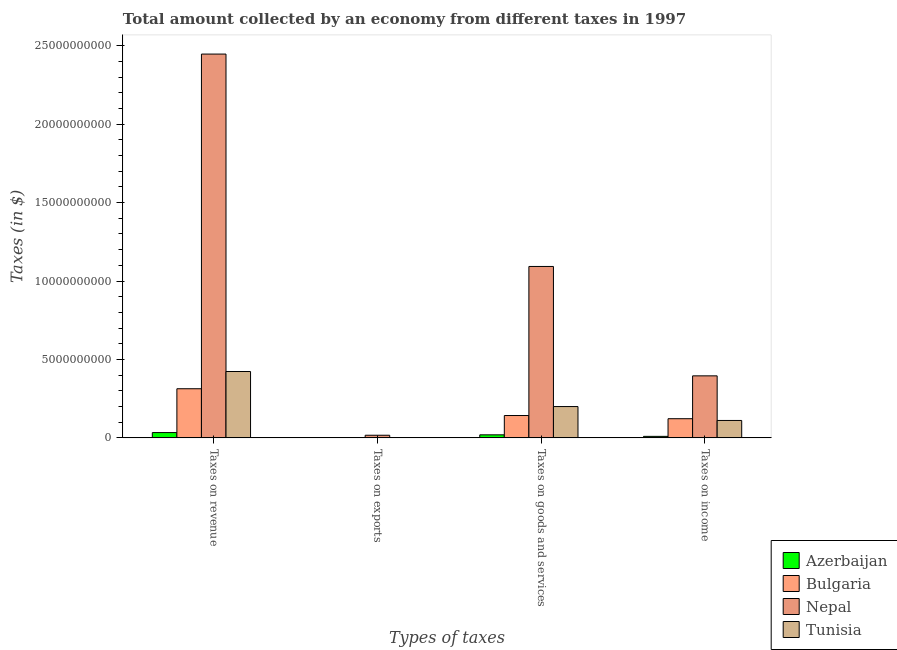How many different coloured bars are there?
Give a very brief answer. 4. Are the number of bars per tick equal to the number of legend labels?
Offer a terse response. Yes. What is the label of the 2nd group of bars from the left?
Offer a very short reply. Taxes on exports. What is the amount collected as tax on exports in Tunisia?
Your response must be concise. 1.02e+07. Across all countries, what is the maximum amount collected as tax on income?
Offer a very short reply. 3.95e+09. Across all countries, what is the minimum amount collected as tax on exports?
Offer a terse response. 9.16e+06. In which country was the amount collected as tax on goods maximum?
Keep it short and to the point. Nepal. In which country was the amount collected as tax on goods minimum?
Give a very brief answer. Azerbaijan. What is the total amount collected as tax on income in the graph?
Make the answer very short. 6.38e+09. What is the difference between the amount collected as tax on income in Bulgaria and that in Nepal?
Your answer should be very brief. -2.73e+09. What is the difference between the amount collected as tax on income in Tunisia and the amount collected as tax on revenue in Bulgaria?
Offer a terse response. -2.02e+09. What is the average amount collected as tax on goods per country?
Ensure brevity in your answer.  3.64e+09. What is the difference between the amount collected as tax on exports and amount collected as tax on revenue in Azerbaijan?
Your response must be concise. -3.29e+08. What is the ratio of the amount collected as tax on goods in Azerbaijan to that in Nepal?
Offer a terse response. 0.02. Is the amount collected as tax on revenue in Nepal less than that in Bulgaria?
Provide a succinct answer. No. Is the difference between the amount collected as tax on exports in Nepal and Tunisia greater than the difference between the amount collected as tax on goods in Nepal and Tunisia?
Provide a succinct answer. No. What is the difference between the highest and the second highest amount collected as tax on exports?
Your response must be concise. 1.56e+08. What is the difference between the highest and the lowest amount collected as tax on goods?
Make the answer very short. 1.07e+1. Is it the case that in every country, the sum of the amount collected as tax on goods and amount collected as tax on income is greater than the sum of amount collected as tax on revenue and amount collected as tax on exports?
Make the answer very short. No. What does the 3rd bar from the left in Taxes on income represents?
Give a very brief answer. Nepal. How many bars are there?
Ensure brevity in your answer.  16. Are all the bars in the graph horizontal?
Keep it short and to the point. No. Are the values on the major ticks of Y-axis written in scientific E-notation?
Offer a terse response. No. Does the graph contain grids?
Offer a terse response. No. Where does the legend appear in the graph?
Your answer should be compact. Bottom right. How many legend labels are there?
Give a very brief answer. 4. What is the title of the graph?
Your answer should be compact. Total amount collected by an economy from different taxes in 1997. What is the label or title of the X-axis?
Ensure brevity in your answer.  Types of taxes. What is the label or title of the Y-axis?
Provide a succinct answer. Taxes (in $). What is the Taxes (in $) of Azerbaijan in Taxes on revenue?
Your answer should be very brief. 3.38e+08. What is the Taxes (in $) of Bulgaria in Taxes on revenue?
Offer a very short reply. 3.13e+09. What is the Taxes (in $) of Nepal in Taxes on revenue?
Provide a short and direct response. 2.45e+1. What is the Taxes (in $) in Tunisia in Taxes on revenue?
Your response must be concise. 4.23e+09. What is the Taxes (in $) of Azerbaijan in Taxes on exports?
Provide a short and direct response. 9.16e+06. What is the Taxes (in $) of Bulgaria in Taxes on exports?
Ensure brevity in your answer.  1.22e+07. What is the Taxes (in $) of Nepal in Taxes on exports?
Provide a short and direct response. 1.68e+08. What is the Taxes (in $) of Tunisia in Taxes on exports?
Offer a terse response. 1.02e+07. What is the Taxes (in $) of Azerbaijan in Taxes on goods and services?
Keep it short and to the point. 1.94e+08. What is the Taxes (in $) of Bulgaria in Taxes on goods and services?
Your response must be concise. 1.42e+09. What is the Taxes (in $) of Nepal in Taxes on goods and services?
Provide a succinct answer. 1.09e+1. What is the Taxes (in $) of Tunisia in Taxes on goods and services?
Your answer should be compact. 2.00e+09. What is the Taxes (in $) of Azerbaijan in Taxes on income?
Provide a short and direct response. 9.60e+07. What is the Taxes (in $) in Bulgaria in Taxes on income?
Your answer should be very brief. 1.22e+09. What is the Taxes (in $) of Nepal in Taxes on income?
Your answer should be compact. 3.95e+09. What is the Taxes (in $) of Tunisia in Taxes on income?
Ensure brevity in your answer.  1.11e+09. Across all Types of taxes, what is the maximum Taxes (in $) of Azerbaijan?
Keep it short and to the point. 3.38e+08. Across all Types of taxes, what is the maximum Taxes (in $) of Bulgaria?
Ensure brevity in your answer.  3.13e+09. Across all Types of taxes, what is the maximum Taxes (in $) of Nepal?
Offer a very short reply. 2.45e+1. Across all Types of taxes, what is the maximum Taxes (in $) of Tunisia?
Offer a very short reply. 4.23e+09. Across all Types of taxes, what is the minimum Taxes (in $) in Azerbaijan?
Ensure brevity in your answer.  9.16e+06. Across all Types of taxes, what is the minimum Taxes (in $) in Bulgaria?
Give a very brief answer. 1.22e+07. Across all Types of taxes, what is the minimum Taxes (in $) in Nepal?
Provide a short and direct response. 1.68e+08. Across all Types of taxes, what is the minimum Taxes (in $) in Tunisia?
Your answer should be compact. 1.02e+07. What is the total Taxes (in $) in Azerbaijan in the graph?
Provide a succinct answer. 6.36e+08. What is the total Taxes (in $) in Bulgaria in the graph?
Provide a short and direct response. 5.79e+09. What is the total Taxes (in $) in Nepal in the graph?
Your response must be concise. 3.95e+1. What is the total Taxes (in $) of Tunisia in the graph?
Provide a succinct answer. 7.35e+09. What is the difference between the Taxes (in $) in Azerbaijan in Taxes on revenue and that in Taxes on exports?
Make the answer very short. 3.29e+08. What is the difference between the Taxes (in $) in Bulgaria in Taxes on revenue and that in Taxes on exports?
Ensure brevity in your answer.  3.12e+09. What is the difference between the Taxes (in $) of Nepal in Taxes on revenue and that in Taxes on exports?
Provide a short and direct response. 2.43e+1. What is the difference between the Taxes (in $) in Tunisia in Taxes on revenue and that in Taxes on exports?
Your answer should be very brief. 4.22e+09. What is the difference between the Taxes (in $) in Azerbaijan in Taxes on revenue and that in Taxes on goods and services?
Your answer should be compact. 1.44e+08. What is the difference between the Taxes (in $) of Bulgaria in Taxes on revenue and that in Taxes on goods and services?
Your answer should be very brief. 1.71e+09. What is the difference between the Taxes (in $) of Nepal in Taxes on revenue and that in Taxes on goods and services?
Keep it short and to the point. 1.35e+1. What is the difference between the Taxes (in $) of Tunisia in Taxes on revenue and that in Taxes on goods and services?
Make the answer very short. 2.23e+09. What is the difference between the Taxes (in $) in Azerbaijan in Taxes on revenue and that in Taxes on income?
Your response must be concise. 2.42e+08. What is the difference between the Taxes (in $) in Bulgaria in Taxes on revenue and that in Taxes on income?
Offer a very short reply. 1.91e+09. What is the difference between the Taxes (in $) in Nepal in Taxes on revenue and that in Taxes on income?
Offer a very short reply. 2.05e+1. What is the difference between the Taxes (in $) of Tunisia in Taxes on revenue and that in Taxes on income?
Ensure brevity in your answer.  3.12e+09. What is the difference between the Taxes (in $) in Azerbaijan in Taxes on exports and that in Taxes on goods and services?
Offer a terse response. -1.84e+08. What is the difference between the Taxes (in $) of Bulgaria in Taxes on exports and that in Taxes on goods and services?
Your response must be concise. -1.41e+09. What is the difference between the Taxes (in $) in Nepal in Taxes on exports and that in Taxes on goods and services?
Offer a terse response. -1.08e+1. What is the difference between the Taxes (in $) of Tunisia in Taxes on exports and that in Taxes on goods and services?
Your answer should be compact. -1.99e+09. What is the difference between the Taxes (in $) in Azerbaijan in Taxes on exports and that in Taxes on income?
Offer a terse response. -8.68e+07. What is the difference between the Taxes (in $) of Bulgaria in Taxes on exports and that in Taxes on income?
Make the answer very short. -1.21e+09. What is the difference between the Taxes (in $) in Nepal in Taxes on exports and that in Taxes on income?
Give a very brief answer. -3.79e+09. What is the difference between the Taxes (in $) in Tunisia in Taxes on exports and that in Taxes on income?
Provide a short and direct response. -1.10e+09. What is the difference between the Taxes (in $) of Azerbaijan in Taxes on goods and services and that in Taxes on income?
Give a very brief answer. 9.75e+07. What is the difference between the Taxes (in $) of Bulgaria in Taxes on goods and services and that in Taxes on income?
Your answer should be compact. 2.02e+08. What is the difference between the Taxes (in $) in Nepal in Taxes on goods and services and that in Taxes on income?
Offer a terse response. 6.98e+09. What is the difference between the Taxes (in $) in Tunisia in Taxes on goods and services and that in Taxes on income?
Your response must be concise. 8.86e+08. What is the difference between the Taxes (in $) of Azerbaijan in Taxes on revenue and the Taxes (in $) of Bulgaria in Taxes on exports?
Your response must be concise. 3.26e+08. What is the difference between the Taxes (in $) of Azerbaijan in Taxes on revenue and the Taxes (in $) of Nepal in Taxes on exports?
Provide a short and direct response. 1.70e+08. What is the difference between the Taxes (in $) in Azerbaijan in Taxes on revenue and the Taxes (in $) in Tunisia in Taxes on exports?
Your answer should be compact. 3.28e+08. What is the difference between the Taxes (in $) in Bulgaria in Taxes on revenue and the Taxes (in $) in Nepal in Taxes on exports?
Provide a short and direct response. 2.96e+09. What is the difference between the Taxes (in $) of Bulgaria in Taxes on revenue and the Taxes (in $) of Tunisia in Taxes on exports?
Provide a short and direct response. 3.12e+09. What is the difference between the Taxes (in $) of Nepal in Taxes on revenue and the Taxes (in $) of Tunisia in Taxes on exports?
Your response must be concise. 2.45e+1. What is the difference between the Taxes (in $) in Azerbaijan in Taxes on revenue and the Taxes (in $) in Bulgaria in Taxes on goods and services?
Give a very brief answer. -1.09e+09. What is the difference between the Taxes (in $) in Azerbaijan in Taxes on revenue and the Taxes (in $) in Nepal in Taxes on goods and services?
Offer a terse response. -1.06e+1. What is the difference between the Taxes (in $) of Azerbaijan in Taxes on revenue and the Taxes (in $) of Tunisia in Taxes on goods and services?
Provide a short and direct response. -1.66e+09. What is the difference between the Taxes (in $) of Bulgaria in Taxes on revenue and the Taxes (in $) of Nepal in Taxes on goods and services?
Make the answer very short. -7.80e+09. What is the difference between the Taxes (in $) of Bulgaria in Taxes on revenue and the Taxes (in $) of Tunisia in Taxes on goods and services?
Provide a succinct answer. 1.14e+09. What is the difference between the Taxes (in $) in Nepal in Taxes on revenue and the Taxes (in $) in Tunisia in Taxes on goods and services?
Ensure brevity in your answer.  2.25e+1. What is the difference between the Taxes (in $) of Azerbaijan in Taxes on revenue and the Taxes (in $) of Bulgaria in Taxes on income?
Your response must be concise. -8.84e+08. What is the difference between the Taxes (in $) in Azerbaijan in Taxes on revenue and the Taxes (in $) in Nepal in Taxes on income?
Provide a succinct answer. -3.62e+09. What is the difference between the Taxes (in $) in Azerbaijan in Taxes on revenue and the Taxes (in $) in Tunisia in Taxes on income?
Your answer should be compact. -7.72e+08. What is the difference between the Taxes (in $) in Bulgaria in Taxes on revenue and the Taxes (in $) in Nepal in Taxes on income?
Offer a terse response. -8.22e+08. What is the difference between the Taxes (in $) of Bulgaria in Taxes on revenue and the Taxes (in $) of Tunisia in Taxes on income?
Your answer should be compact. 2.02e+09. What is the difference between the Taxes (in $) in Nepal in Taxes on revenue and the Taxes (in $) in Tunisia in Taxes on income?
Your answer should be compact. 2.34e+1. What is the difference between the Taxes (in $) of Azerbaijan in Taxes on exports and the Taxes (in $) of Bulgaria in Taxes on goods and services?
Provide a short and direct response. -1.42e+09. What is the difference between the Taxes (in $) in Azerbaijan in Taxes on exports and the Taxes (in $) in Nepal in Taxes on goods and services?
Ensure brevity in your answer.  -1.09e+1. What is the difference between the Taxes (in $) in Azerbaijan in Taxes on exports and the Taxes (in $) in Tunisia in Taxes on goods and services?
Make the answer very short. -1.99e+09. What is the difference between the Taxes (in $) in Bulgaria in Taxes on exports and the Taxes (in $) in Nepal in Taxes on goods and services?
Ensure brevity in your answer.  -1.09e+1. What is the difference between the Taxes (in $) of Bulgaria in Taxes on exports and the Taxes (in $) of Tunisia in Taxes on goods and services?
Your answer should be compact. -1.98e+09. What is the difference between the Taxes (in $) of Nepal in Taxes on exports and the Taxes (in $) of Tunisia in Taxes on goods and services?
Keep it short and to the point. -1.83e+09. What is the difference between the Taxes (in $) of Azerbaijan in Taxes on exports and the Taxes (in $) of Bulgaria in Taxes on income?
Provide a short and direct response. -1.21e+09. What is the difference between the Taxes (in $) of Azerbaijan in Taxes on exports and the Taxes (in $) of Nepal in Taxes on income?
Make the answer very short. -3.94e+09. What is the difference between the Taxes (in $) in Azerbaijan in Taxes on exports and the Taxes (in $) in Tunisia in Taxes on income?
Your answer should be compact. -1.10e+09. What is the difference between the Taxes (in $) in Bulgaria in Taxes on exports and the Taxes (in $) in Nepal in Taxes on income?
Offer a terse response. -3.94e+09. What is the difference between the Taxes (in $) of Bulgaria in Taxes on exports and the Taxes (in $) of Tunisia in Taxes on income?
Make the answer very short. -1.10e+09. What is the difference between the Taxes (in $) of Nepal in Taxes on exports and the Taxes (in $) of Tunisia in Taxes on income?
Your answer should be very brief. -9.42e+08. What is the difference between the Taxes (in $) of Azerbaijan in Taxes on goods and services and the Taxes (in $) of Bulgaria in Taxes on income?
Your answer should be very brief. -1.03e+09. What is the difference between the Taxes (in $) in Azerbaijan in Taxes on goods and services and the Taxes (in $) in Nepal in Taxes on income?
Provide a short and direct response. -3.76e+09. What is the difference between the Taxes (in $) in Azerbaijan in Taxes on goods and services and the Taxes (in $) in Tunisia in Taxes on income?
Ensure brevity in your answer.  -9.16e+08. What is the difference between the Taxes (in $) of Bulgaria in Taxes on goods and services and the Taxes (in $) of Nepal in Taxes on income?
Keep it short and to the point. -2.53e+09. What is the difference between the Taxes (in $) in Bulgaria in Taxes on goods and services and the Taxes (in $) in Tunisia in Taxes on income?
Your answer should be very brief. 3.14e+08. What is the difference between the Taxes (in $) of Nepal in Taxes on goods and services and the Taxes (in $) of Tunisia in Taxes on income?
Provide a succinct answer. 9.82e+09. What is the average Taxes (in $) of Azerbaijan per Types of taxes?
Keep it short and to the point. 1.59e+08. What is the average Taxes (in $) in Bulgaria per Types of taxes?
Give a very brief answer. 1.45e+09. What is the average Taxes (in $) of Nepal per Types of taxes?
Your answer should be very brief. 9.88e+09. What is the average Taxes (in $) in Tunisia per Types of taxes?
Provide a succinct answer. 1.84e+09. What is the difference between the Taxes (in $) in Azerbaijan and Taxes (in $) in Bulgaria in Taxes on revenue?
Offer a very short reply. -2.79e+09. What is the difference between the Taxes (in $) in Azerbaijan and Taxes (in $) in Nepal in Taxes on revenue?
Make the answer very short. -2.41e+1. What is the difference between the Taxes (in $) in Azerbaijan and Taxes (in $) in Tunisia in Taxes on revenue?
Ensure brevity in your answer.  -3.89e+09. What is the difference between the Taxes (in $) of Bulgaria and Taxes (in $) of Nepal in Taxes on revenue?
Your answer should be compact. -2.13e+1. What is the difference between the Taxes (in $) in Bulgaria and Taxes (in $) in Tunisia in Taxes on revenue?
Your answer should be compact. -1.10e+09. What is the difference between the Taxes (in $) of Nepal and Taxes (in $) of Tunisia in Taxes on revenue?
Offer a very short reply. 2.02e+1. What is the difference between the Taxes (in $) of Azerbaijan and Taxes (in $) of Bulgaria in Taxes on exports?
Ensure brevity in your answer.  -3.06e+06. What is the difference between the Taxes (in $) of Azerbaijan and Taxes (in $) of Nepal in Taxes on exports?
Your response must be concise. -1.59e+08. What is the difference between the Taxes (in $) in Azerbaijan and Taxes (in $) in Tunisia in Taxes on exports?
Provide a short and direct response. -1.04e+06. What is the difference between the Taxes (in $) of Bulgaria and Taxes (in $) of Nepal in Taxes on exports?
Your response must be concise. -1.56e+08. What is the difference between the Taxes (in $) in Bulgaria and Taxes (in $) in Tunisia in Taxes on exports?
Provide a short and direct response. 2.02e+06. What is the difference between the Taxes (in $) in Nepal and Taxes (in $) in Tunisia in Taxes on exports?
Offer a very short reply. 1.58e+08. What is the difference between the Taxes (in $) of Azerbaijan and Taxes (in $) of Bulgaria in Taxes on goods and services?
Make the answer very short. -1.23e+09. What is the difference between the Taxes (in $) in Azerbaijan and Taxes (in $) in Nepal in Taxes on goods and services?
Provide a succinct answer. -1.07e+1. What is the difference between the Taxes (in $) in Azerbaijan and Taxes (in $) in Tunisia in Taxes on goods and services?
Your response must be concise. -1.80e+09. What is the difference between the Taxes (in $) of Bulgaria and Taxes (in $) of Nepal in Taxes on goods and services?
Ensure brevity in your answer.  -9.50e+09. What is the difference between the Taxes (in $) of Bulgaria and Taxes (in $) of Tunisia in Taxes on goods and services?
Give a very brief answer. -5.72e+08. What is the difference between the Taxes (in $) in Nepal and Taxes (in $) in Tunisia in Taxes on goods and services?
Provide a short and direct response. 8.93e+09. What is the difference between the Taxes (in $) in Azerbaijan and Taxes (in $) in Bulgaria in Taxes on income?
Make the answer very short. -1.13e+09. What is the difference between the Taxes (in $) of Azerbaijan and Taxes (in $) of Nepal in Taxes on income?
Make the answer very short. -3.86e+09. What is the difference between the Taxes (in $) in Azerbaijan and Taxes (in $) in Tunisia in Taxes on income?
Make the answer very short. -1.01e+09. What is the difference between the Taxes (in $) of Bulgaria and Taxes (in $) of Nepal in Taxes on income?
Offer a very short reply. -2.73e+09. What is the difference between the Taxes (in $) of Bulgaria and Taxes (in $) of Tunisia in Taxes on income?
Keep it short and to the point. 1.12e+08. What is the difference between the Taxes (in $) of Nepal and Taxes (in $) of Tunisia in Taxes on income?
Ensure brevity in your answer.  2.84e+09. What is the ratio of the Taxes (in $) of Azerbaijan in Taxes on revenue to that in Taxes on exports?
Keep it short and to the point. 36.85. What is the ratio of the Taxes (in $) of Bulgaria in Taxes on revenue to that in Taxes on exports?
Offer a terse response. 256.26. What is the ratio of the Taxes (in $) of Nepal in Taxes on revenue to that in Taxes on exports?
Make the answer very short. 145.66. What is the ratio of the Taxes (in $) in Tunisia in Taxes on revenue to that in Taxes on exports?
Provide a succinct answer. 414.8. What is the ratio of the Taxes (in $) in Azerbaijan in Taxes on revenue to that in Taxes on goods and services?
Ensure brevity in your answer.  1.75. What is the ratio of the Taxes (in $) in Bulgaria in Taxes on revenue to that in Taxes on goods and services?
Provide a succinct answer. 2.2. What is the ratio of the Taxes (in $) of Nepal in Taxes on revenue to that in Taxes on goods and services?
Offer a terse response. 2.24. What is the ratio of the Taxes (in $) of Tunisia in Taxes on revenue to that in Taxes on goods and services?
Provide a succinct answer. 2.12. What is the ratio of the Taxes (in $) in Azerbaijan in Taxes on revenue to that in Taxes on income?
Give a very brief answer. 3.52. What is the ratio of the Taxes (in $) of Bulgaria in Taxes on revenue to that in Taxes on income?
Provide a short and direct response. 2.56. What is the ratio of the Taxes (in $) in Nepal in Taxes on revenue to that in Taxes on income?
Offer a terse response. 6.19. What is the ratio of the Taxes (in $) in Tunisia in Taxes on revenue to that in Taxes on income?
Your answer should be compact. 3.81. What is the ratio of the Taxes (in $) in Azerbaijan in Taxes on exports to that in Taxes on goods and services?
Give a very brief answer. 0.05. What is the ratio of the Taxes (in $) of Bulgaria in Taxes on exports to that in Taxes on goods and services?
Ensure brevity in your answer.  0.01. What is the ratio of the Taxes (in $) of Nepal in Taxes on exports to that in Taxes on goods and services?
Your answer should be compact. 0.02. What is the ratio of the Taxes (in $) in Tunisia in Taxes on exports to that in Taxes on goods and services?
Keep it short and to the point. 0.01. What is the ratio of the Taxes (in $) of Azerbaijan in Taxes on exports to that in Taxes on income?
Offer a very short reply. 0.1. What is the ratio of the Taxes (in $) in Nepal in Taxes on exports to that in Taxes on income?
Your answer should be very brief. 0.04. What is the ratio of the Taxes (in $) in Tunisia in Taxes on exports to that in Taxes on income?
Give a very brief answer. 0.01. What is the ratio of the Taxes (in $) in Azerbaijan in Taxes on goods and services to that in Taxes on income?
Provide a short and direct response. 2.02. What is the ratio of the Taxes (in $) in Bulgaria in Taxes on goods and services to that in Taxes on income?
Ensure brevity in your answer.  1.17. What is the ratio of the Taxes (in $) of Nepal in Taxes on goods and services to that in Taxes on income?
Your answer should be compact. 2.76. What is the ratio of the Taxes (in $) of Tunisia in Taxes on goods and services to that in Taxes on income?
Provide a short and direct response. 1.8. What is the difference between the highest and the second highest Taxes (in $) of Azerbaijan?
Your answer should be very brief. 1.44e+08. What is the difference between the highest and the second highest Taxes (in $) of Bulgaria?
Offer a very short reply. 1.71e+09. What is the difference between the highest and the second highest Taxes (in $) in Nepal?
Provide a succinct answer. 1.35e+1. What is the difference between the highest and the second highest Taxes (in $) of Tunisia?
Your response must be concise. 2.23e+09. What is the difference between the highest and the lowest Taxes (in $) in Azerbaijan?
Your answer should be very brief. 3.29e+08. What is the difference between the highest and the lowest Taxes (in $) of Bulgaria?
Offer a very short reply. 3.12e+09. What is the difference between the highest and the lowest Taxes (in $) in Nepal?
Give a very brief answer. 2.43e+1. What is the difference between the highest and the lowest Taxes (in $) of Tunisia?
Your answer should be very brief. 4.22e+09. 